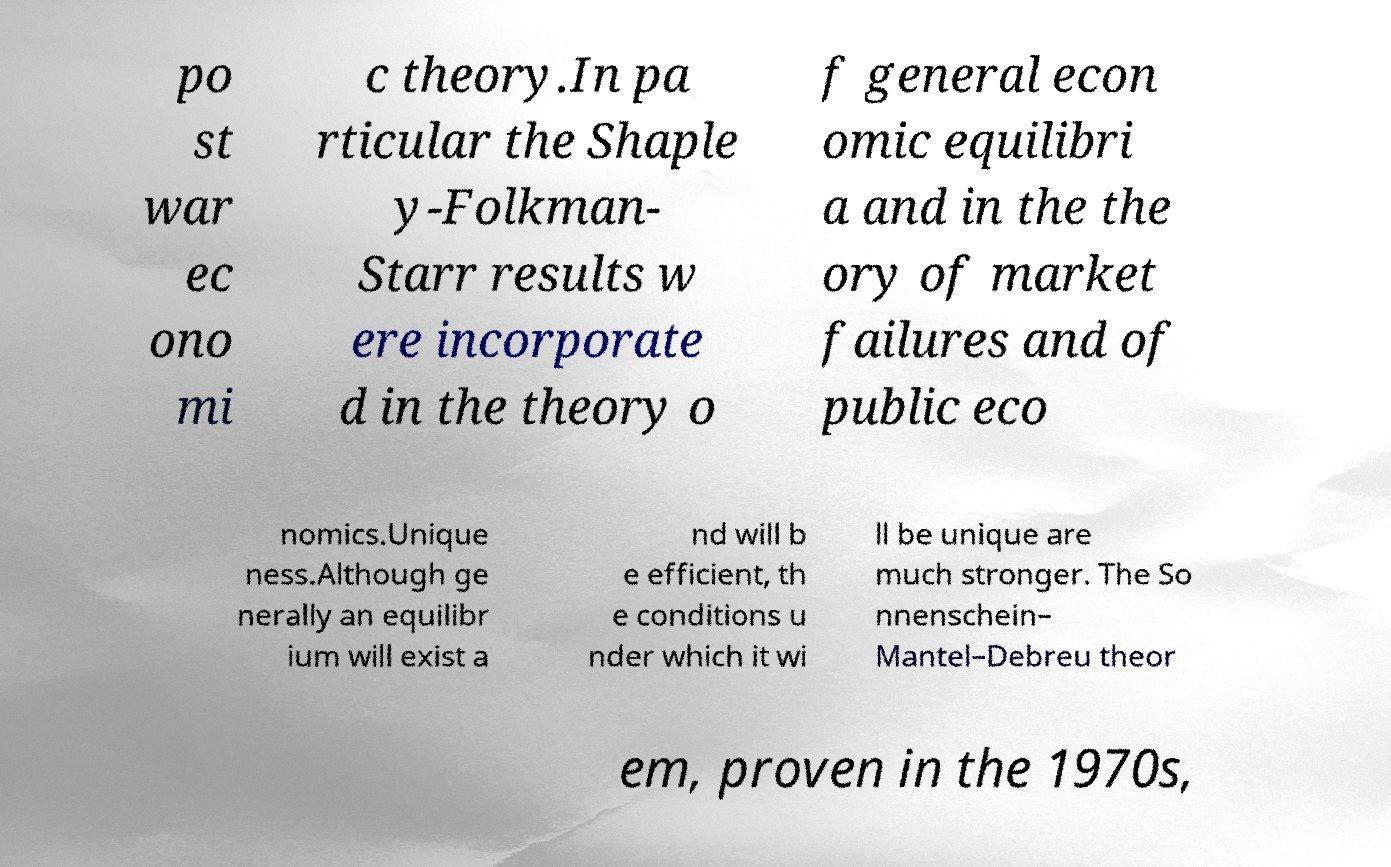Please read and relay the text visible in this image. What does it say? po st war ec ono mi c theory.In pa rticular the Shaple y-Folkman- Starr results w ere incorporate d in the theory o f general econ omic equilibri a and in the the ory of market failures and of public eco nomics.Unique ness.Although ge nerally an equilibr ium will exist a nd will b e efficient, th e conditions u nder which it wi ll be unique are much stronger. The So nnenschein– Mantel–Debreu theor em, proven in the 1970s, 